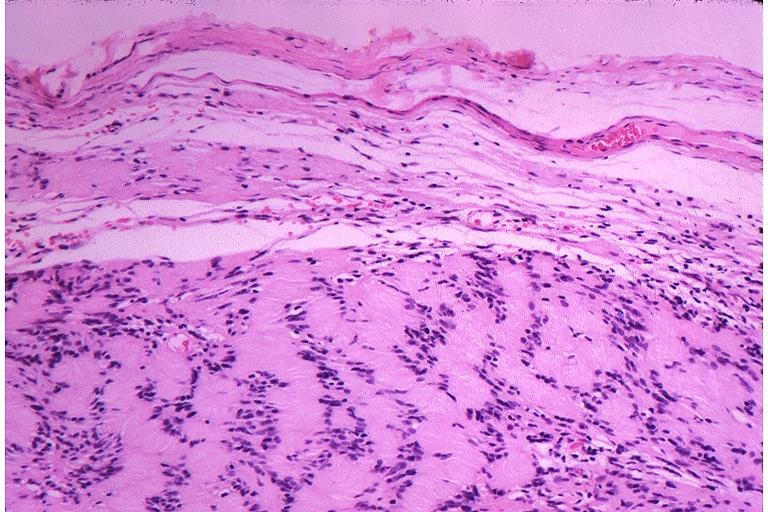where is this?
Answer the question using a single word or phrase. Oral 